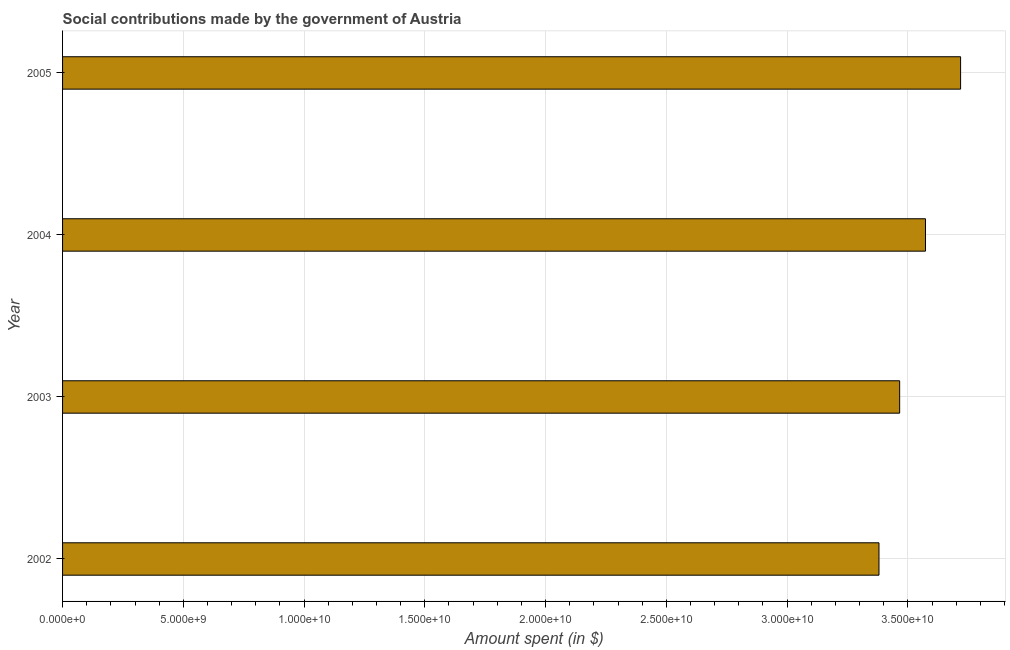Does the graph contain any zero values?
Your response must be concise. No. Does the graph contain grids?
Ensure brevity in your answer.  Yes. What is the title of the graph?
Offer a terse response. Social contributions made by the government of Austria. What is the label or title of the X-axis?
Make the answer very short. Amount spent (in $). What is the amount spent in making social contributions in 2002?
Your answer should be very brief. 3.38e+1. Across all years, what is the maximum amount spent in making social contributions?
Your answer should be compact. 3.72e+1. Across all years, what is the minimum amount spent in making social contributions?
Your answer should be compact. 3.38e+1. In which year was the amount spent in making social contributions maximum?
Offer a terse response. 2005. What is the sum of the amount spent in making social contributions?
Your answer should be very brief. 1.41e+11. What is the difference between the amount spent in making social contributions in 2003 and 2004?
Give a very brief answer. -1.07e+09. What is the average amount spent in making social contributions per year?
Keep it short and to the point. 3.53e+1. What is the median amount spent in making social contributions?
Your answer should be very brief. 3.52e+1. In how many years, is the amount spent in making social contributions greater than 33000000000 $?
Offer a very short reply. 4. What is the ratio of the amount spent in making social contributions in 2003 to that in 2004?
Give a very brief answer. 0.97. Is the amount spent in making social contributions in 2002 less than that in 2003?
Make the answer very short. Yes. Is the difference between the amount spent in making social contributions in 2004 and 2005 greater than the difference between any two years?
Provide a succinct answer. No. What is the difference between the highest and the second highest amount spent in making social contributions?
Provide a short and direct response. 1.45e+09. Is the sum of the amount spent in making social contributions in 2002 and 2004 greater than the maximum amount spent in making social contributions across all years?
Your answer should be compact. Yes. What is the difference between the highest and the lowest amount spent in making social contributions?
Your response must be concise. 3.38e+09. How many bars are there?
Your answer should be compact. 4. Are all the bars in the graph horizontal?
Give a very brief answer. Yes. Are the values on the major ticks of X-axis written in scientific E-notation?
Keep it short and to the point. Yes. What is the Amount spent (in $) in 2002?
Ensure brevity in your answer.  3.38e+1. What is the Amount spent (in $) in 2003?
Offer a very short reply. 3.47e+1. What is the Amount spent (in $) in 2004?
Give a very brief answer. 3.57e+1. What is the Amount spent (in $) of 2005?
Your answer should be very brief. 3.72e+1. What is the difference between the Amount spent (in $) in 2002 and 2003?
Offer a terse response. -8.56e+08. What is the difference between the Amount spent (in $) in 2002 and 2004?
Give a very brief answer. -1.92e+09. What is the difference between the Amount spent (in $) in 2002 and 2005?
Ensure brevity in your answer.  -3.38e+09. What is the difference between the Amount spent (in $) in 2003 and 2004?
Your answer should be very brief. -1.07e+09. What is the difference between the Amount spent (in $) in 2003 and 2005?
Your response must be concise. -2.52e+09. What is the difference between the Amount spent (in $) in 2004 and 2005?
Your answer should be compact. -1.45e+09. What is the ratio of the Amount spent (in $) in 2002 to that in 2004?
Offer a terse response. 0.95. What is the ratio of the Amount spent (in $) in 2002 to that in 2005?
Give a very brief answer. 0.91. What is the ratio of the Amount spent (in $) in 2003 to that in 2005?
Your answer should be very brief. 0.93. 